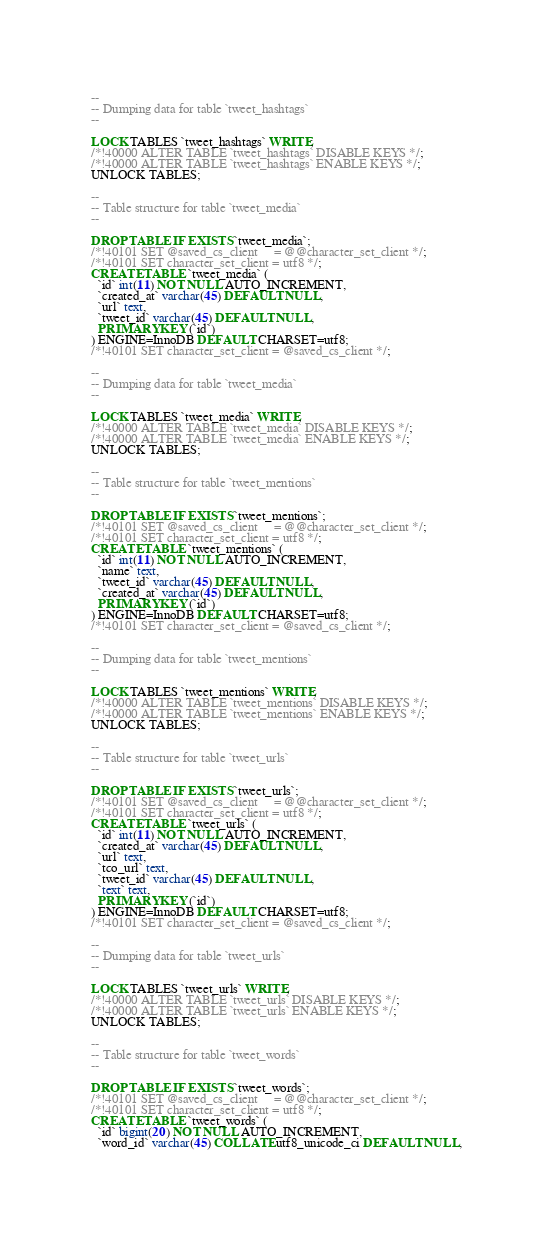Convert code to text. <code><loc_0><loc_0><loc_500><loc_500><_SQL_>--
-- Dumping data for table `tweet_hashtags`
--

LOCK TABLES `tweet_hashtags` WRITE;
/*!40000 ALTER TABLE `tweet_hashtags` DISABLE KEYS */;
/*!40000 ALTER TABLE `tweet_hashtags` ENABLE KEYS */;
UNLOCK TABLES;

--
-- Table structure for table `tweet_media`
--

DROP TABLE IF EXISTS `tweet_media`;
/*!40101 SET @saved_cs_client     = @@character_set_client */;
/*!40101 SET character_set_client = utf8 */;
CREATE TABLE `tweet_media` (
  `id` int(11) NOT NULL AUTO_INCREMENT,
  `created_at` varchar(45) DEFAULT NULL,
  `url` text,
  `tweet_id` varchar(45) DEFAULT NULL,
  PRIMARY KEY (`id`)
) ENGINE=InnoDB DEFAULT CHARSET=utf8;
/*!40101 SET character_set_client = @saved_cs_client */;

--
-- Dumping data for table `tweet_media`
--

LOCK TABLES `tweet_media` WRITE;
/*!40000 ALTER TABLE `tweet_media` DISABLE KEYS */;
/*!40000 ALTER TABLE `tweet_media` ENABLE KEYS */;
UNLOCK TABLES;

--
-- Table structure for table `tweet_mentions`
--

DROP TABLE IF EXISTS `tweet_mentions`;
/*!40101 SET @saved_cs_client     = @@character_set_client */;
/*!40101 SET character_set_client = utf8 */;
CREATE TABLE `tweet_mentions` (
  `id` int(11) NOT NULL AUTO_INCREMENT,
  `name` text,
  `tweet_id` varchar(45) DEFAULT NULL,
  `created_at` varchar(45) DEFAULT NULL,
  PRIMARY KEY (`id`)
) ENGINE=InnoDB DEFAULT CHARSET=utf8;
/*!40101 SET character_set_client = @saved_cs_client */;

--
-- Dumping data for table `tweet_mentions`
--

LOCK TABLES `tweet_mentions` WRITE;
/*!40000 ALTER TABLE `tweet_mentions` DISABLE KEYS */;
/*!40000 ALTER TABLE `tweet_mentions` ENABLE KEYS */;
UNLOCK TABLES;

--
-- Table structure for table `tweet_urls`
--

DROP TABLE IF EXISTS `tweet_urls`;
/*!40101 SET @saved_cs_client     = @@character_set_client */;
/*!40101 SET character_set_client = utf8 */;
CREATE TABLE `tweet_urls` (
  `id` int(11) NOT NULL AUTO_INCREMENT,
  `created_at` varchar(45) DEFAULT NULL,
  `url` text,
  `tco_url` text,
  `tweet_id` varchar(45) DEFAULT NULL,
  `text` text,
  PRIMARY KEY (`id`)
) ENGINE=InnoDB DEFAULT CHARSET=utf8;
/*!40101 SET character_set_client = @saved_cs_client */;

--
-- Dumping data for table `tweet_urls`
--

LOCK TABLES `tweet_urls` WRITE;
/*!40000 ALTER TABLE `tweet_urls` DISABLE KEYS */;
/*!40000 ALTER TABLE `tweet_urls` ENABLE KEYS */;
UNLOCK TABLES;

--
-- Table structure for table `tweet_words`
--

DROP TABLE IF EXISTS `tweet_words`;
/*!40101 SET @saved_cs_client     = @@character_set_client */;
/*!40101 SET character_set_client = utf8 */;
CREATE TABLE `tweet_words` (
  `id` bigint(20) NOT NULL AUTO_INCREMENT,
  `word_id` varchar(45) COLLATE utf8_unicode_ci DEFAULT NULL,</code> 